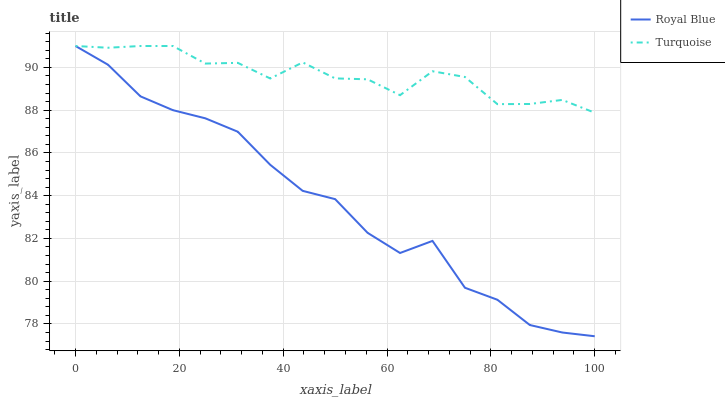Does Turquoise have the minimum area under the curve?
Answer yes or no. No. Is Turquoise the smoothest?
Answer yes or no. No. Does Turquoise have the lowest value?
Answer yes or no. No. 